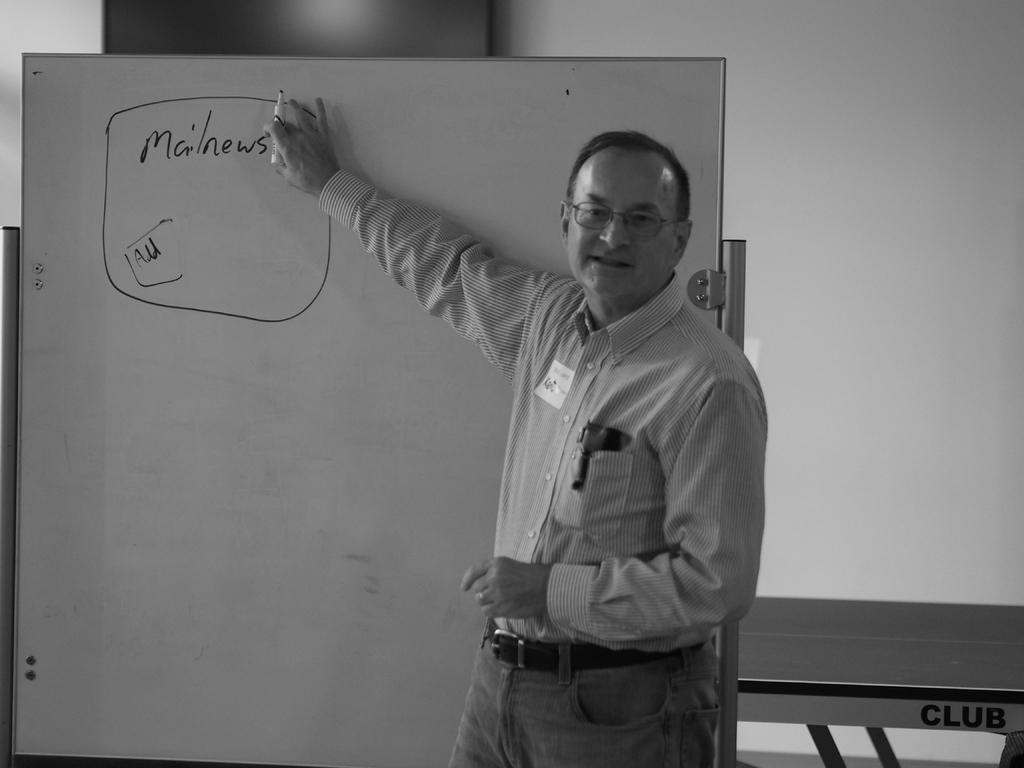What is the person in the image doing? The person is standing in the image and holding a pen. What is the person possibly about to do with the pen? The person might be about to write on the whiteboard, as they are holding a pen. What can be seen on the whiteboard in the image? There is text written on the whiteboard in the image. What is visible in the background of the image? There is a table and a wall in the background of the image. What type of sweater is the person wearing in the image? There is no sweater visible in the image; the person is not wearing any clothing. Is there a volcano erupting in the background of the image? No, there is no volcano present in the image. 